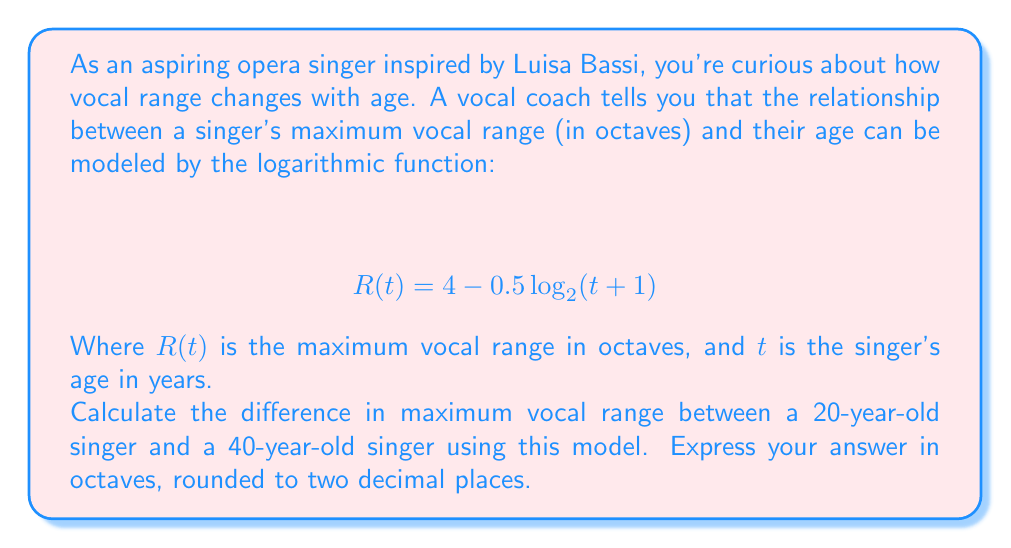What is the answer to this math problem? Let's approach this step-by-step:

1) We need to calculate $R(20)$ and $R(40)$, then find their difference.

2) For $R(20)$:
   $$ R(20) = 4 - 0.5 \log_2(20+1) $$
   $$ = 4 - 0.5 \log_2(21) $$
   $$ = 4 - 0.5 * 4.39231742 $$
   $$ = 4 - 2.19615871 $$
   $$ = 1.80384129 \text{ octaves} $$

3) For $R(40)$:
   $$ R(40) = 4 - 0.5 \log_2(40+1) $$
   $$ = 4 - 0.5 \log_2(41) $$
   $$ = 4 - 0.5 * 5.35754733 $$
   $$ = 4 - 2.67877366 $$
   $$ = 1.32122634 \text{ octaves} $$

4) The difference in range:
   $$ 1.80384129 - 1.32122634 = 0.48261495 \text{ octaves} $$

5) Rounding to two decimal places:
   $$ 0.48261495 \approx 0.48 \text{ octaves} $$

This result shows that, according to this model, a 20-year-old singer would have a maximum vocal range about 0.48 octaves wider than a 40-year-old singer.
Answer: 0.48 octaves 